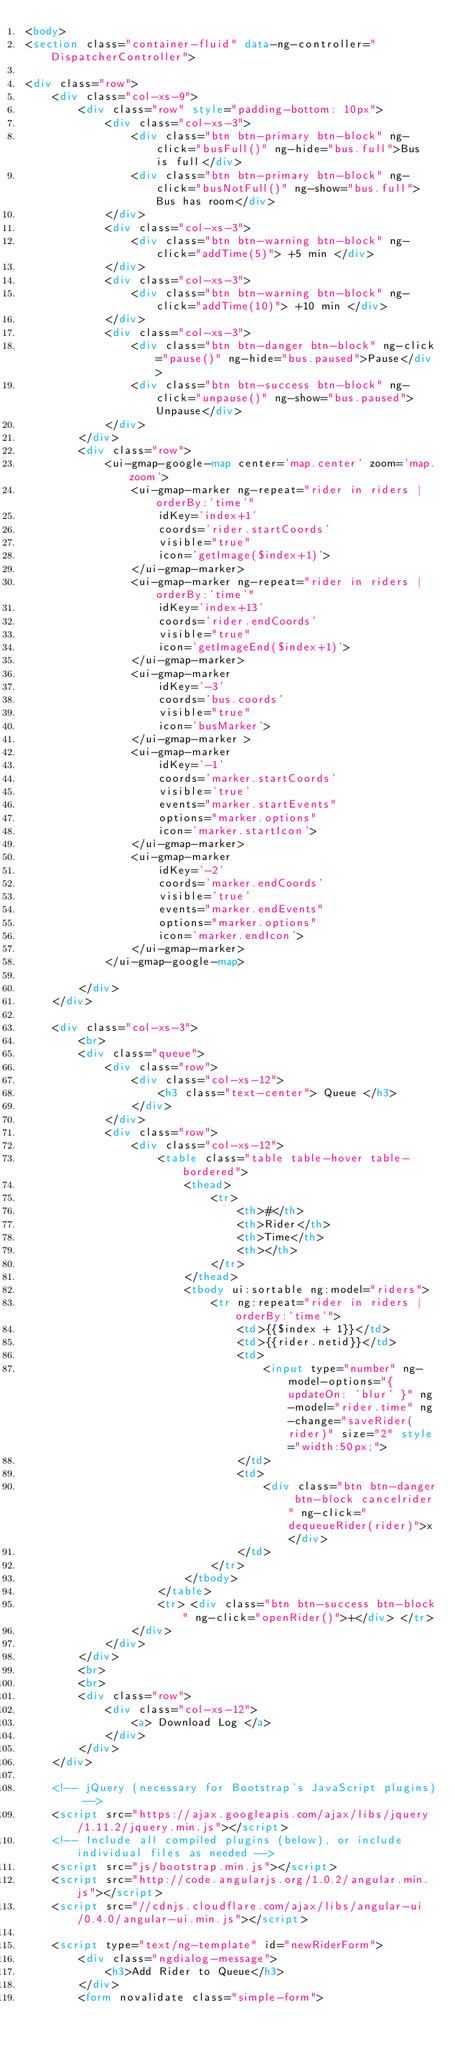<code> <loc_0><loc_0><loc_500><loc_500><_HTML_><body>
<section class="container-fluid" data-ng-controller="DispatcherController">

<div class="row">
	<div class="col-xs-9">
		<div class="row" style="padding-bottom: 10px">
			<div class="col-xs-3">
				<div class="btn btn-primary btn-block" ng-click="busFull()" ng-hide="bus.full">Bus is full</div>
				<div class="btn btn-primary btn-block" ng-click="busNotFull()" ng-show="bus.full">Bus has room</div>
			</div>
			<div class="col-xs-3">
				<div class="btn btn-warning btn-block" ng-click="addTime(5)"> +5 min </div>
			</div>
			<div class="col-xs-3">
				<div class="btn btn-warning btn-block" ng-click="addTime(10)"> +10 min </div>
			</div>
			<div class="col-xs-3">
				<div class="btn btn-danger btn-block" ng-click="pause()" ng-hide="bus.paused">Pause</div>
				<div class="btn btn-success btn-block" ng-click="unpause()" ng-show="bus.paused">Unpause</div>
			</div>
		</div>
		<div class="row">
			<ui-gmap-google-map center='map.center' zoom='map.zoom'>
				<ui-gmap-marker ng-repeat="rider in riders | orderBy:'time'"
		 			idKey='index+1'
		 			coords='rider.startCoords'
		 			visible="true"
		 			icon='getImage($index+1)'>
		 		</ui-gmap-marker>
		 		<ui-gmap-marker ng-repeat="rider in riders | orderBy:'time'"
		 			idKey='index+13'
		 			coords='rider.endCoords'
		 			visible="true"
		 			icon='getImageEnd($index+1)'>
		 		</ui-gmap-marker>
		 		<ui-gmap-marker 
		 			idKey='-3'
		 			coords='bus.coords'
		 			visible="true"
		 			icon='busMarker'>
				</ui-gmap-marker >
				<ui-gmap-marker 
		 			idKey='-1'
		 			coords='marker.startCoords'
		 			visible='true'
		 			events="marker.startEvents"
		 			options="marker.options"
		 			icon='marker.startIcon'>
		 		</ui-gmap-marker>
		 		<ui-gmap-marker 
		 			idKey='-2'
		 			coords='marker.endCoords'
		 			visible='true'
		 			events="marker.endEvents"
		 			options="marker.options"
		 			icon='marker.endIcon'>
		 		</ui-gmap-marker>
			</ui-gmap-google-map>
			 
		</div>
	</div>

	<div class="col-xs-3">
		<br>
		<div class="queue">
			<div class="row">
				<div class="col-xs-12">
					<h3 class="text-center"> Queue </h3>
				</div>
			</div>
			<div class="row">
				<div class="col-xs-12">
					<table class="table table-hover table-bordered">
				  		<thead>
				            <tr>
				                <th>#</th>
				                <th>Rider</th>
				                <th>Time</th>
				                <th></th>
				            </tr>
				        </thead>
				        <tbody ui:sortable ng:model="riders">
				            <tr ng:repeat="rider in riders | orderBy:'time'">
				                <td>{{$index + 1}}</td>
				                <td>{{rider.netid}}</td>
				                <td> 
				                	<input type="number" ng-model-options="{ updateOn: 'blur' }" ng-model="rider.time" ng-change="saveRider(rider)" size="2" style="width:50px;"> 
				                </td>
				                <td>
				                	<div class="btn btn-danger btn-block cancelrider" ng-click="dequeueRider(rider)">x</div>
				                </td>
				            </tr>
				        </tbody>
					</table>
					<tr> <div class="btn btn-success btn-block" ng-click="openRider()">+</div> </tr>
				</div>
			</div>
		</div>
		<br>
		<br>
		<div class="row">
			<div class="col-xs-12">
				<a> Download Log </a>
			</div>
		</div>
	</div>		

	<!-- jQuery (necessary for Bootstrap's JavaScript plugins) -->
    <script src="https://ajax.googleapis.com/ajax/libs/jquery/1.11.2/jquery.min.js"></script>
    <!-- Include all compiled plugins (below), or include individual files as needed -->
    <script src="js/bootstrap.min.js"></script>
    <script src="http://code.angularjs.org/1.0.2/angular.min.js"></script>
	<script src="//cdnjs.cloudflare.com/ajax/libs/angular-ui/0.4.0/angular-ui.min.js"></script>

	<script type="text/ng-template" id="newRiderForm">
		<div class="ngdialog-message">
			<h3>Add Rider to Queue</h3>
		</div>
		<form novalidate class="simple-form"></code> 